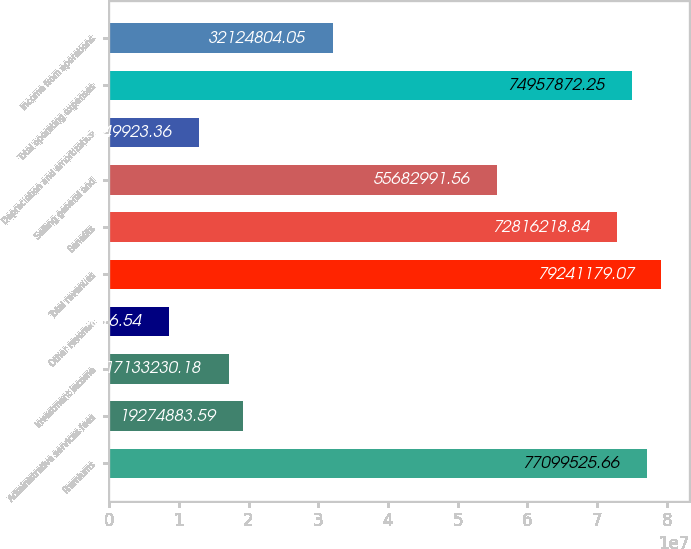<chart> <loc_0><loc_0><loc_500><loc_500><bar_chart><fcel>Premiums<fcel>Administrative services fees<fcel>Investment income<fcel>Other revenue<fcel>Total revenues<fcel>Benefits<fcel>Selling general and<fcel>Depreciation and amortization<fcel>Total operating expenses<fcel>Income from operations<nl><fcel>7.70995e+07<fcel>1.92749e+07<fcel>1.71332e+07<fcel>8.56662e+06<fcel>7.92412e+07<fcel>7.28162e+07<fcel>5.5683e+07<fcel>1.28499e+07<fcel>7.49579e+07<fcel>3.21248e+07<nl></chart> 